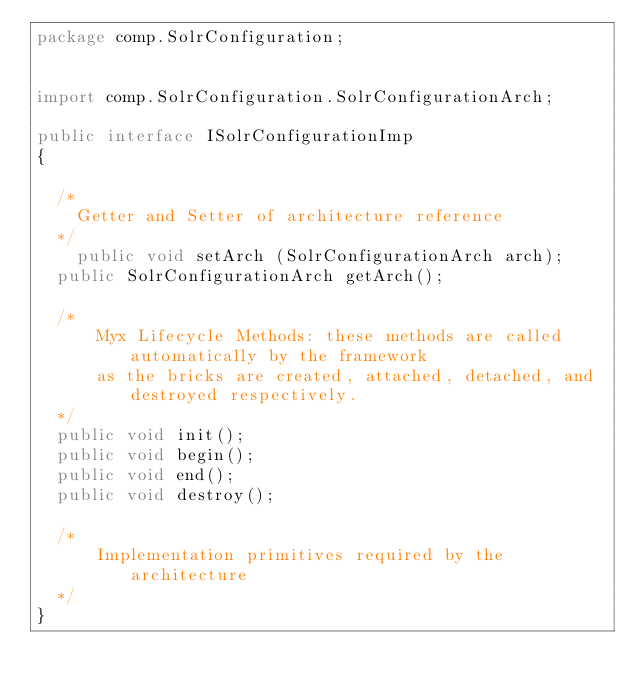<code> <loc_0><loc_0><loc_500><loc_500><_Java_>package comp.SolrConfiguration;


import comp.SolrConfiguration.SolrConfigurationArch;

public interface ISolrConfigurationImp 
{

	/*
	  Getter and Setter of architecture reference
	*/
    public void setArch (SolrConfigurationArch arch);
	public SolrConfigurationArch getArch();
	
	/*
  	  Myx Lifecycle Methods: these methods are called automatically by the framework
  	  as the bricks are created, attached, detached, and destroyed respectively.
	*/	
	public void init();	
	public void begin();
	public void end();
	public void destroy();

	/*
  	  Implementation primitives required by the architecture
	*/
}</code> 